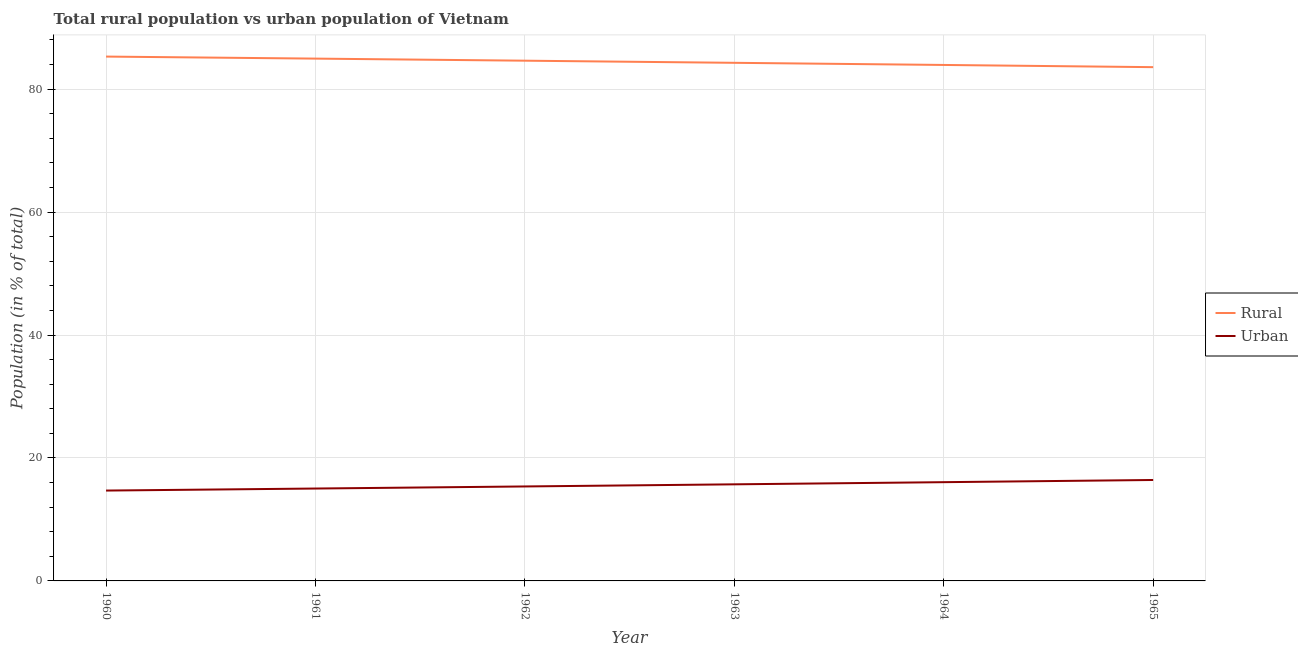Does the line corresponding to rural population intersect with the line corresponding to urban population?
Offer a very short reply. No. What is the urban population in 1963?
Give a very brief answer. 15.71. Across all years, what is the maximum urban population?
Offer a terse response. 16.42. In which year was the rural population maximum?
Your answer should be compact. 1960. What is the total urban population in the graph?
Keep it short and to the point. 93.3. What is the difference between the urban population in 1962 and that in 1965?
Ensure brevity in your answer.  -1.05. What is the difference between the urban population in 1961 and the rural population in 1960?
Make the answer very short. -70.27. What is the average urban population per year?
Your answer should be compact. 15.55. In the year 1965, what is the difference between the rural population and urban population?
Your answer should be compact. 67.16. In how many years, is the rural population greater than 56 %?
Provide a short and direct response. 6. What is the ratio of the rural population in 1962 to that in 1963?
Ensure brevity in your answer.  1. Is the rural population in 1960 less than that in 1964?
Your answer should be compact. No. Is the difference between the urban population in 1964 and 1965 greater than the difference between the rural population in 1964 and 1965?
Give a very brief answer. No. What is the difference between the highest and the second highest rural population?
Make the answer very short. 0.33. What is the difference between the highest and the lowest urban population?
Make the answer very short. 1.72. Is the urban population strictly greater than the rural population over the years?
Your response must be concise. No. Is the rural population strictly less than the urban population over the years?
Provide a succinct answer. No. How many lines are there?
Give a very brief answer. 2. How many years are there in the graph?
Ensure brevity in your answer.  6. Are the values on the major ticks of Y-axis written in scientific E-notation?
Offer a terse response. No. How are the legend labels stacked?
Offer a very short reply. Vertical. What is the title of the graph?
Ensure brevity in your answer.  Total rural population vs urban population of Vietnam. Does "Under-five" appear as one of the legend labels in the graph?
Provide a short and direct response. No. What is the label or title of the Y-axis?
Keep it short and to the point. Population (in % of total). What is the Population (in % of total) in Rural in 1960?
Give a very brief answer. 85.3. What is the Population (in % of total) of Rural in 1961?
Your answer should be compact. 84.97. What is the Population (in % of total) in Urban in 1961?
Offer a very short reply. 15.03. What is the Population (in % of total) in Rural in 1962?
Provide a short and direct response. 84.63. What is the Population (in % of total) in Urban in 1962?
Offer a terse response. 15.37. What is the Population (in % of total) of Rural in 1963?
Offer a very short reply. 84.29. What is the Population (in % of total) of Urban in 1963?
Provide a succinct answer. 15.71. What is the Population (in % of total) of Rural in 1964?
Provide a succinct answer. 83.94. What is the Population (in % of total) of Urban in 1964?
Ensure brevity in your answer.  16.06. What is the Population (in % of total) of Rural in 1965?
Your answer should be very brief. 83.58. What is the Population (in % of total) in Urban in 1965?
Ensure brevity in your answer.  16.42. Across all years, what is the maximum Population (in % of total) of Rural?
Provide a succinct answer. 85.3. Across all years, what is the maximum Population (in % of total) in Urban?
Your response must be concise. 16.42. Across all years, what is the minimum Population (in % of total) of Rural?
Your answer should be compact. 83.58. What is the total Population (in % of total) in Rural in the graph?
Provide a succinct answer. 506.7. What is the total Population (in % of total) in Urban in the graph?
Make the answer very short. 93.3. What is the difference between the Population (in % of total) of Rural in 1960 and that in 1961?
Provide a succinct answer. 0.33. What is the difference between the Population (in % of total) in Urban in 1960 and that in 1961?
Your answer should be very brief. -0.33. What is the difference between the Population (in % of total) in Rural in 1960 and that in 1962?
Provide a short and direct response. 0.67. What is the difference between the Population (in % of total) in Urban in 1960 and that in 1962?
Your response must be concise. -0.67. What is the difference between the Population (in % of total) in Urban in 1960 and that in 1963?
Offer a very short reply. -1.01. What is the difference between the Population (in % of total) of Rural in 1960 and that in 1964?
Your answer should be compact. 1.36. What is the difference between the Population (in % of total) of Urban in 1960 and that in 1964?
Ensure brevity in your answer.  -1.36. What is the difference between the Population (in % of total) of Rural in 1960 and that in 1965?
Your answer should be very brief. 1.72. What is the difference between the Population (in % of total) in Urban in 1960 and that in 1965?
Your response must be concise. -1.72. What is the difference between the Population (in % of total) of Rural in 1961 and that in 1962?
Give a very brief answer. 0.34. What is the difference between the Population (in % of total) of Urban in 1961 and that in 1962?
Your response must be concise. -0.34. What is the difference between the Population (in % of total) of Rural in 1961 and that in 1963?
Your answer should be compact. 0.68. What is the difference between the Population (in % of total) of Urban in 1961 and that in 1963?
Offer a terse response. -0.68. What is the difference between the Population (in % of total) in Rural in 1961 and that in 1964?
Keep it short and to the point. 1.03. What is the difference between the Population (in % of total) of Urban in 1961 and that in 1964?
Your response must be concise. -1.03. What is the difference between the Population (in % of total) of Rural in 1961 and that in 1965?
Keep it short and to the point. 1.39. What is the difference between the Population (in % of total) of Urban in 1961 and that in 1965?
Your answer should be very brief. -1.39. What is the difference between the Population (in % of total) in Rural in 1962 and that in 1963?
Give a very brief answer. 0.34. What is the difference between the Population (in % of total) of Urban in 1962 and that in 1963?
Your response must be concise. -0.34. What is the difference between the Population (in % of total) in Rural in 1962 and that in 1964?
Keep it short and to the point. 0.69. What is the difference between the Population (in % of total) of Urban in 1962 and that in 1964?
Provide a succinct answer. -0.69. What is the difference between the Population (in % of total) in Rural in 1962 and that in 1965?
Provide a short and direct response. 1.05. What is the difference between the Population (in % of total) in Urban in 1962 and that in 1965?
Provide a short and direct response. -1.05. What is the difference between the Population (in % of total) of Rural in 1963 and that in 1964?
Your answer should be very brief. 0.35. What is the difference between the Population (in % of total) of Urban in 1963 and that in 1964?
Offer a terse response. -0.35. What is the difference between the Population (in % of total) in Rural in 1963 and that in 1965?
Your answer should be very brief. 0.71. What is the difference between the Population (in % of total) of Urban in 1963 and that in 1965?
Your answer should be very brief. -0.71. What is the difference between the Population (in % of total) of Rural in 1964 and that in 1965?
Offer a very short reply. 0.36. What is the difference between the Population (in % of total) in Urban in 1964 and that in 1965?
Ensure brevity in your answer.  -0.36. What is the difference between the Population (in % of total) in Rural in 1960 and the Population (in % of total) in Urban in 1961?
Keep it short and to the point. 70.27. What is the difference between the Population (in % of total) in Rural in 1960 and the Population (in % of total) in Urban in 1962?
Offer a terse response. 69.93. What is the difference between the Population (in % of total) of Rural in 1960 and the Population (in % of total) of Urban in 1963?
Your answer should be very brief. 69.59. What is the difference between the Population (in % of total) in Rural in 1960 and the Population (in % of total) in Urban in 1964?
Provide a succinct answer. 69.24. What is the difference between the Population (in % of total) in Rural in 1960 and the Population (in % of total) in Urban in 1965?
Your answer should be compact. 68.88. What is the difference between the Population (in % of total) of Rural in 1961 and the Population (in % of total) of Urban in 1962?
Make the answer very short. 69.6. What is the difference between the Population (in % of total) of Rural in 1961 and the Population (in % of total) of Urban in 1963?
Provide a succinct answer. 69.25. What is the difference between the Population (in % of total) in Rural in 1961 and the Population (in % of total) in Urban in 1964?
Your answer should be very brief. 68.91. What is the difference between the Population (in % of total) in Rural in 1961 and the Population (in % of total) in Urban in 1965?
Your answer should be compact. 68.55. What is the difference between the Population (in % of total) of Rural in 1962 and the Population (in % of total) of Urban in 1963?
Give a very brief answer. 68.92. What is the difference between the Population (in % of total) in Rural in 1962 and the Population (in % of total) in Urban in 1964?
Make the answer very short. 68.57. What is the difference between the Population (in % of total) of Rural in 1962 and the Population (in % of total) of Urban in 1965?
Your answer should be very brief. 68.21. What is the difference between the Population (in % of total) in Rural in 1963 and the Population (in % of total) in Urban in 1964?
Provide a short and direct response. 68.22. What is the difference between the Population (in % of total) in Rural in 1963 and the Population (in % of total) in Urban in 1965?
Your response must be concise. 67.86. What is the difference between the Population (in % of total) in Rural in 1964 and the Population (in % of total) in Urban in 1965?
Ensure brevity in your answer.  67.52. What is the average Population (in % of total) of Rural per year?
Your answer should be very brief. 84.45. What is the average Population (in % of total) of Urban per year?
Offer a terse response. 15.55. In the year 1960, what is the difference between the Population (in % of total) of Rural and Population (in % of total) of Urban?
Your answer should be very brief. 70.6. In the year 1961, what is the difference between the Population (in % of total) in Rural and Population (in % of total) in Urban?
Offer a terse response. 69.94. In the year 1962, what is the difference between the Population (in % of total) of Rural and Population (in % of total) of Urban?
Ensure brevity in your answer.  69.26. In the year 1963, what is the difference between the Population (in % of total) in Rural and Population (in % of total) in Urban?
Ensure brevity in your answer.  68.57. In the year 1964, what is the difference between the Population (in % of total) of Rural and Population (in % of total) of Urban?
Your answer should be very brief. 67.87. In the year 1965, what is the difference between the Population (in % of total) in Rural and Population (in % of total) in Urban?
Your response must be concise. 67.16. What is the ratio of the Population (in % of total) of Urban in 1960 to that in 1961?
Offer a very short reply. 0.98. What is the ratio of the Population (in % of total) in Rural in 1960 to that in 1962?
Offer a very short reply. 1.01. What is the ratio of the Population (in % of total) in Urban in 1960 to that in 1962?
Your response must be concise. 0.96. What is the ratio of the Population (in % of total) of Rural in 1960 to that in 1963?
Offer a terse response. 1.01. What is the ratio of the Population (in % of total) of Urban in 1960 to that in 1963?
Your answer should be compact. 0.94. What is the ratio of the Population (in % of total) of Rural in 1960 to that in 1964?
Keep it short and to the point. 1.02. What is the ratio of the Population (in % of total) in Urban in 1960 to that in 1964?
Offer a terse response. 0.92. What is the ratio of the Population (in % of total) in Rural in 1960 to that in 1965?
Offer a terse response. 1.02. What is the ratio of the Population (in % of total) in Urban in 1960 to that in 1965?
Offer a very short reply. 0.9. What is the ratio of the Population (in % of total) in Rural in 1961 to that in 1962?
Keep it short and to the point. 1. What is the ratio of the Population (in % of total) in Urban in 1961 to that in 1962?
Your response must be concise. 0.98. What is the ratio of the Population (in % of total) in Urban in 1961 to that in 1963?
Offer a very short reply. 0.96. What is the ratio of the Population (in % of total) in Rural in 1961 to that in 1964?
Provide a succinct answer. 1.01. What is the ratio of the Population (in % of total) of Urban in 1961 to that in 1964?
Your response must be concise. 0.94. What is the ratio of the Population (in % of total) of Rural in 1961 to that in 1965?
Offer a very short reply. 1.02. What is the ratio of the Population (in % of total) of Urban in 1961 to that in 1965?
Give a very brief answer. 0.92. What is the ratio of the Population (in % of total) in Urban in 1962 to that in 1963?
Make the answer very short. 0.98. What is the ratio of the Population (in % of total) in Rural in 1962 to that in 1964?
Offer a very short reply. 1.01. What is the ratio of the Population (in % of total) in Urban in 1962 to that in 1964?
Your response must be concise. 0.96. What is the ratio of the Population (in % of total) of Rural in 1962 to that in 1965?
Make the answer very short. 1.01. What is the ratio of the Population (in % of total) in Urban in 1962 to that in 1965?
Your answer should be very brief. 0.94. What is the ratio of the Population (in % of total) of Urban in 1963 to that in 1964?
Your answer should be compact. 0.98. What is the ratio of the Population (in % of total) in Rural in 1963 to that in 1965?
Ensure brevity in your answer.  1.01. What is the ratio of the Population (in % of total) of Urban in 1963 to that in 1965?
Offer a terse response. 0.96. What is the ratio of the Population (in % of total) in Urban in 1964 to that in 1965?
Give a very brief answer. 0.98. What is the difference between the highest and the second highest Population (in % of total) in Rural?
Offer a terse response. 0.33. What is the difference between the highest and the second highest Population (in % of total) in Urban?
Provide a short and direct response. 0.36. What is the difference between the highest and the lowest Population (in % of total) in Rural?
Offer a terse response. 1.72. What is the difference between the highest and the lowest Population (in % of total) in Urban?
Provide a short and direct response. 1.72. 